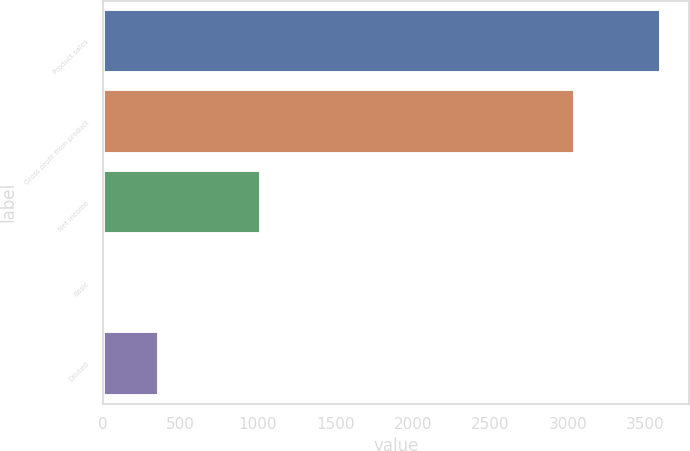<chart> <loc_0><loc_0><loc_500><loc_500><bar_chart><fcel>Product sales<fcel>Gross profit from product<fcel>Net income<fcel>Basic<fcel>Diluted<nl><fcel>3604<fcel>3046<fcel>1019<fcel>0.9<fcel>361.21<nl></chart> 